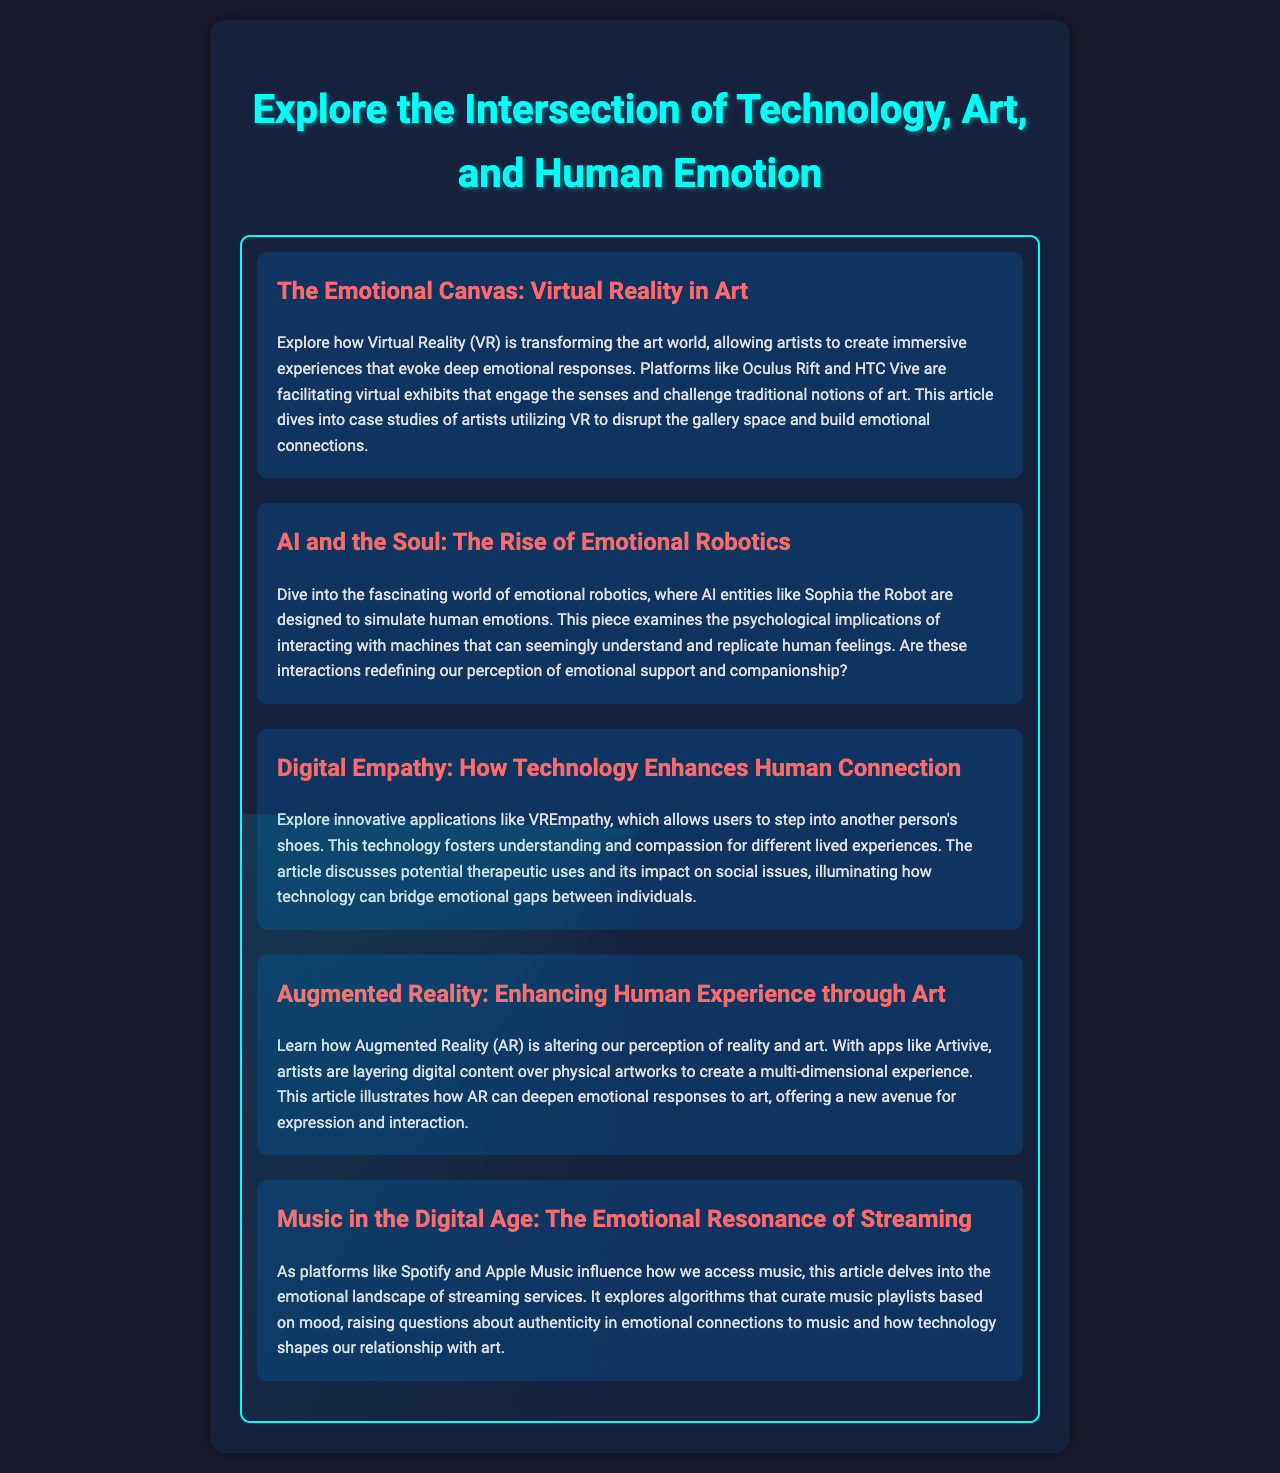What is the title of the magazine? The title of the magazine is presented in the header of the document, focusing on the fusion of technology, art, and emotion.
Answer: Explore the Intersection of Technology, Art, and Human Emotion How many articles are featured in the magazine? The document includes a section with five distinct articles, each addressing unique themes.
Answer: 5 What is the first article about? The first article's title and description detail how VR is enriching the art world and emotional experiences.
Answer: The Emotional Canvas: Virtual Reality in Art What technology allows users to step into another person's shoes? The document references a specific application aimed at deepening empathy and understanding.
Answer: VREmpathy What do streaming platforms influence, according to one article? The section of the document discussing music highlights the emotional aspect impacted by access to music.
Answer: Emotional landscape Which technology is mentioned as enhancing human experience through art? The document outlines how a specific technology is used to layer digital content over physical artworks.
Answer: Augmented Reality How does the article about emotional robotics pose a question? This article suggests a philosophical inquiry about the nature of emotional interactions with machines.
Answer: Are these interactions redefining our perception of emotional support and companionship? What color is primarily used for headings in the magazine? The document describes the color scheme employed for headings, particularly in terms of emotional visibility.
Answer: Red What is the overall background color of the magazine? The document specifies the background color used throughout the magazine for visual consistency and atmosphere.
Answer: Dark blue 